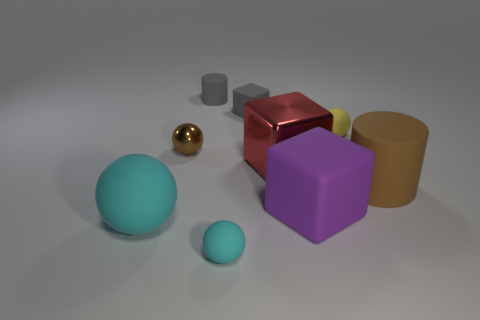Is the number of large matte spheres greater than the number of small rubber balls?
Give a very brief answer. No. What is the color of the cylinder that is in front of the matte cube that is behind the metal thing right of the small matte cube?
Offer a very short reply. Brown. Do the gray matte object to the right of the tiny matte cylinder and the purple matte object have the same shape?
Provide a short and direct response. Yes. There is a cube that is the same size as the red object; what color is it?
Keep it short and to the point. Purple. What number of rubber cylinders are there?
Your answer should be very brief. 2. Is the cylinder that is behind the big matte cylinder made of the same material as the purple thing?
Ensure brevity in your answer.  Yes. There is a sphere that is on the right side of the tiny matte cylinder and in front of the big red thing; what is its material?
Keep it short and to the point. Rubber. The cylinder that is the same color as the tiny matte cube is what size?
Keep it short and to the point. Small. There is a cyan thing that is on the right side of the small ball left of the small cylinder; what is it made of?
Keep it short and to the point. Rubber. There is a brown object behind the big object that is to the right of the cube in front of the big shiny object; what size is it?
Your response must be concise. Small. 